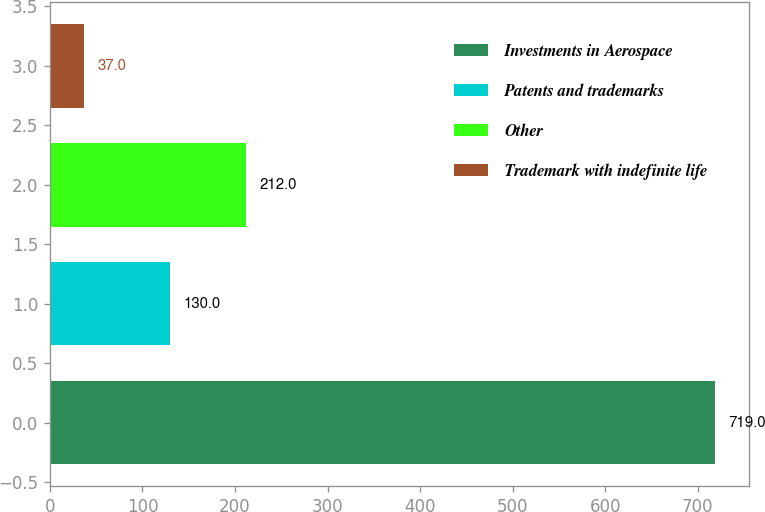<chart> <loc_0><loc_0><loc_500><loc_500><bar_chart><fcel>Investments in Aerospace<fcel>Patents and trademarks<fcel>Other<fcel>Trademark with indefinite life<nl><fcel>719<fcel>130<fcel>212<fcel>37<nl></chart> 